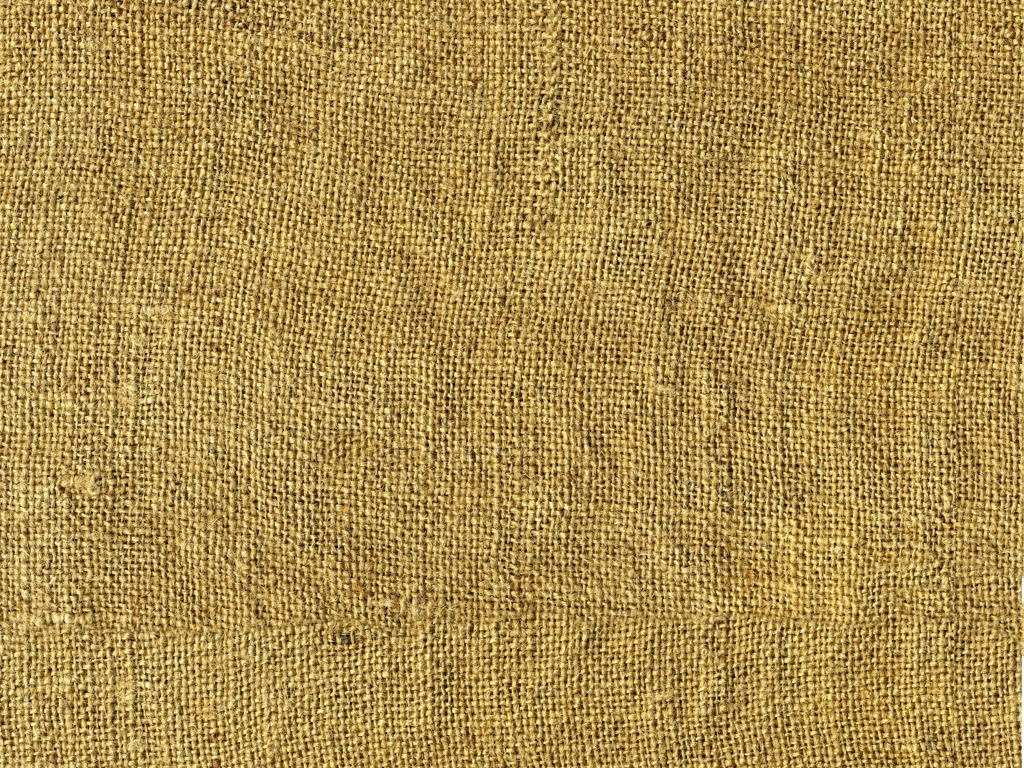What material does this texture resemble? The texture in the image appears to resemble a burlap fabric, commonly known for its coarse and natural fiber texture, often used in sackcloth and for agricultural purposes. 